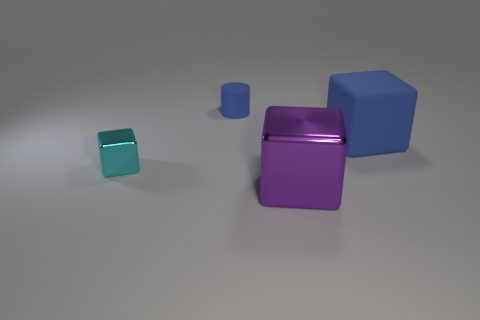What is the color of the thing that is the same size as the rubber cube?
Your answer should be compact. Purple. There is a matte object on the right side of the big purple block; is its color the same as the tiny shiny cube?
Keep it short and to the point. No. Is there a green cube that has the same material as the small blue cylinder?
Ensure brevity in your answer.  No. What shape is the other object that is the same color as the big rubber thing?
Offer a terse response. Cylinder. Is the number of metal cubes that are behind the cyan shiny cube less than the number of cylinders?
Give a very brief answer. Yes. There is a rubber thing that is behind the blue block; is its size the same as the purple metallic cube?
Offer a very short reply. No. How many big purple metallic objects have the same shape as the tiny shiny thing?
Keep it short and to the point. 1. There is another thing that is made of the same material as the big purple object; what is its size?
Keep it short and to the point. Small. Are there an equal number of cyan objects in front of the rubber cube and purple shiny objects?
Offer a terse response. Yes. Do the tiny cube and the rubber cube have the same color?
Provide a succinct answer. No. 